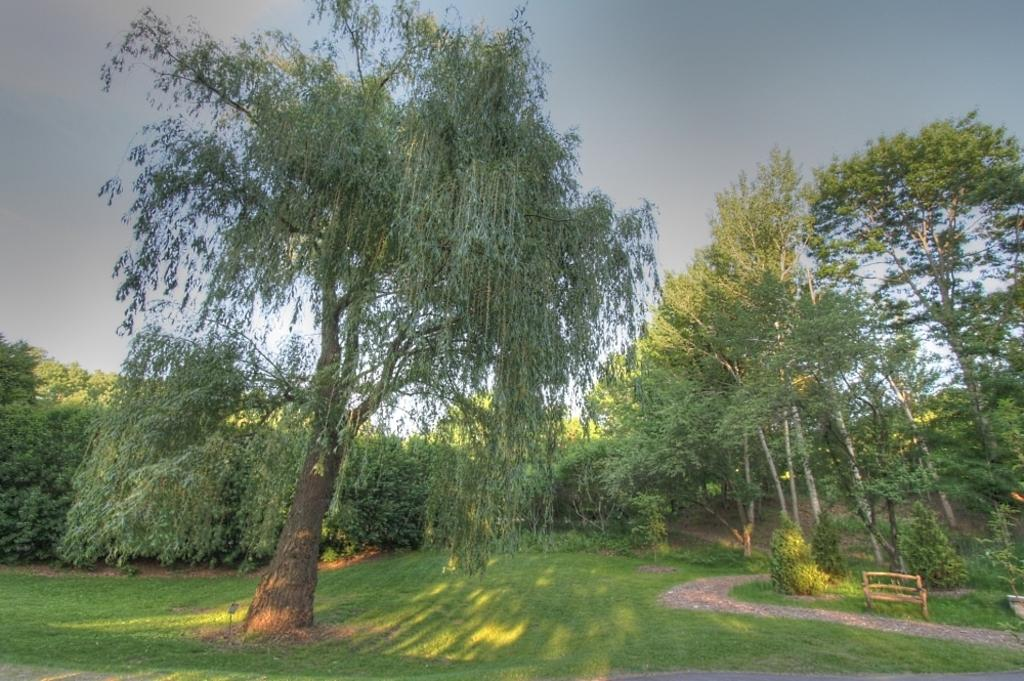What type of vegetation is present in the image? There is grass and trees in the image. What type of structure is visible in the image? There is a bench in the image. What is the chance of winning a friend in the image? There is no reference to winning or friends in the image; it features grass, trees, and a bench. 